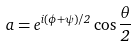<formula> <loc_0><loc_0><loc_500><loc_500>a = e ^ { i ( \phi + \psi ) / 2 } \cos \frac { \theta } { 2 }</formula> 